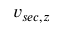<formula> <loc_0><loc_0><loc_500><loc_500>v _ { s e c , z }</formula> 